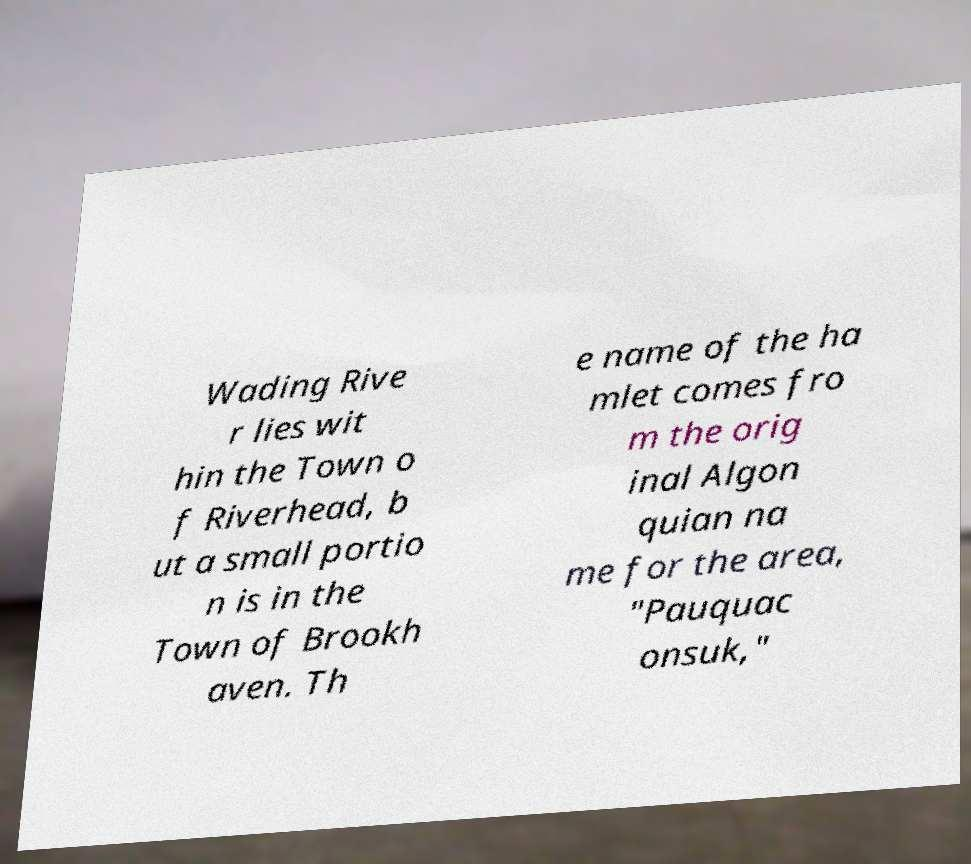There's text embedded in this image that I need extracted. Can you transcribe it verbatim? Wading Rive r lies wit hin the Town o f Riverhead, b ut a small portio n is in the Town of Brookh aven. Th e name of the ha mlet comes fro m the orig inal Algon quian na me for the area, "Pauquac onsuk," 